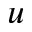Convert formula to latex. <formula><loc_0><loc_0><loc_500><loc_500>u</formula> 